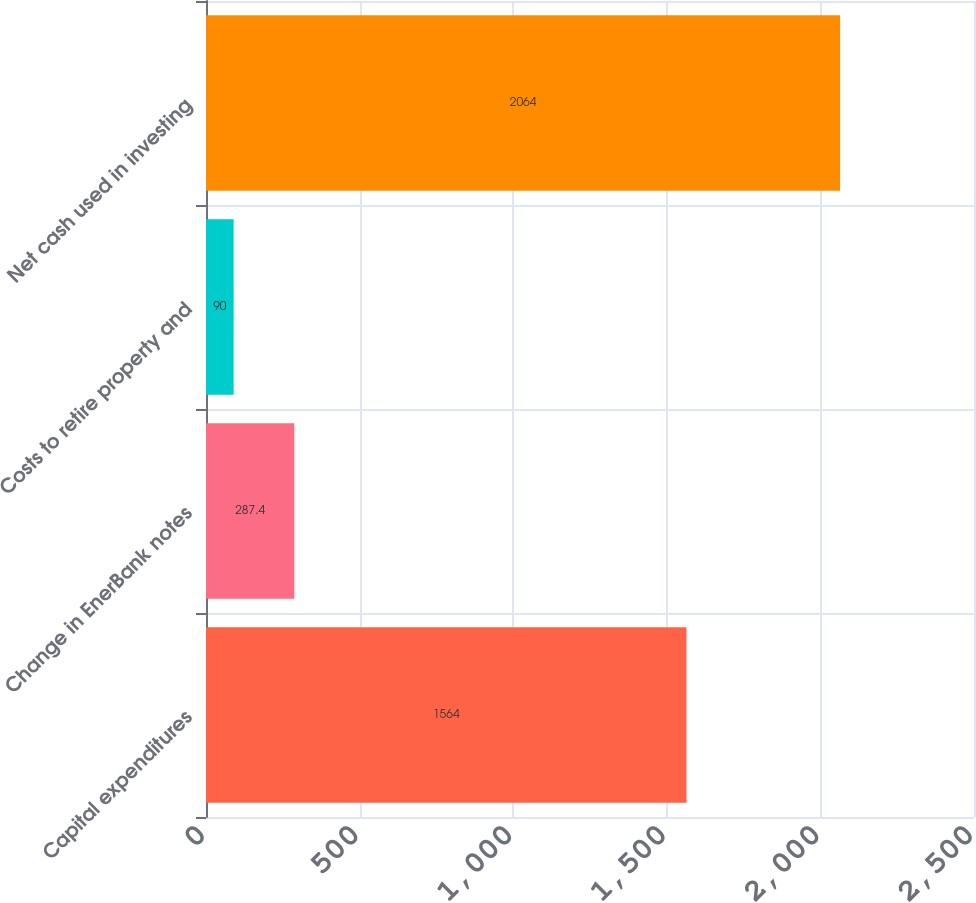Convert chart to OTSL. <chart><loc_0><loc_0><loc_500><loc_500><bar_chart><fcel>Capital expenditures<fcel>Change in EnerBank notes<fcel>Costs to retire property and<fcel>Net cash used in investing<nl><fcel>1564<fcel>287.4<fcel>90<fcel>2064<nl></chart> 